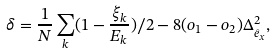<formula> <loc_0><loc_0><loc_500><loc_500>\delta = \frac { 1 } { N } \sum _ { k } ( 1 - \frac { \xi _ { k } } { E _ { k } } ) / 2 - 8 ( o _ { 1 } - o _ { 2 } ) \Delta _ { \hat { e } _ { x } } ^ { 2 } ,</formula> 